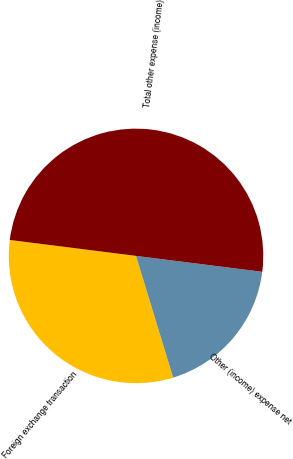Convert chart. <chart><loc_0><loc_0><loc_500><loc_500><pie_chart><fcel>Foreign exchange transaction<fcel>Other (income) expense net<fcel>Total other expense (income)<nl><fcel>31.71%<fcel>18.29%<fcel>50.0%<nl></chart> 